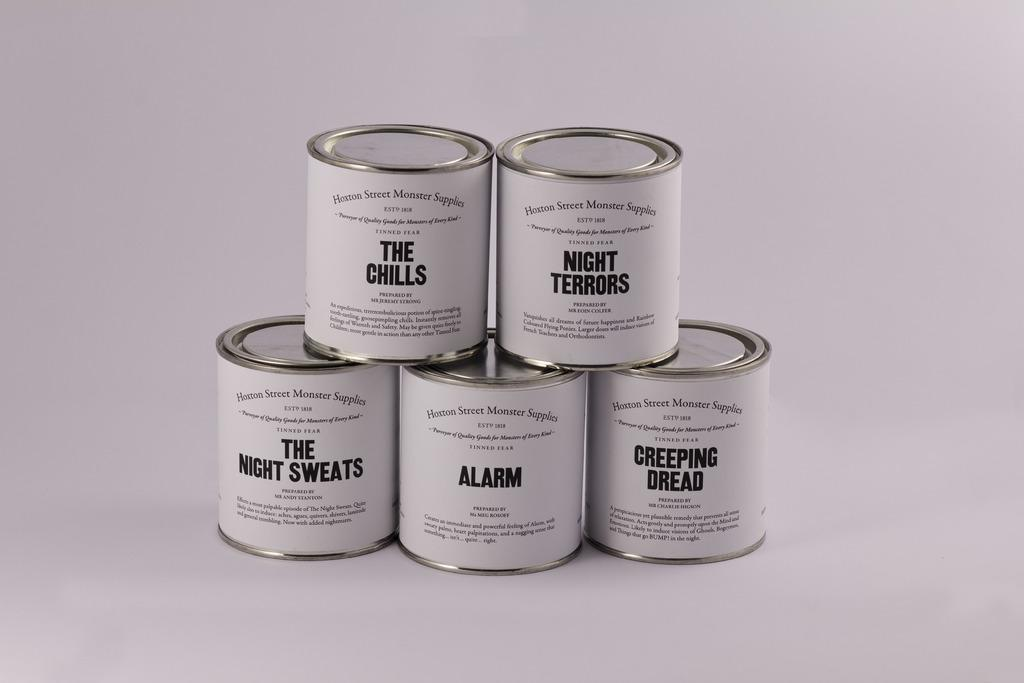What type of string can be seen in the mine in the image? There is no mine or string present in the image. What country is depicted in the image? The image does not depict any specific country. What type of string can be seen in the mine in the image? There is no mine or string present in the image. What country is depicted in the image? The image does not depict any specific country. Reasoning: Let's think step by step in order to create an absurd question and answer based on the given absurd topics. We start by acknowledging that there are no specific facts provided about the image. Then, we create an absurd question that combines two of the given absurd topics (string and mine) and ask about their presence in the image, knowing that they are not actually present. Finally, we create an absurd question that combines the remaining absurd topic (country) and ask about its depiction in the image, knowing that the image does not depict any specific country. 